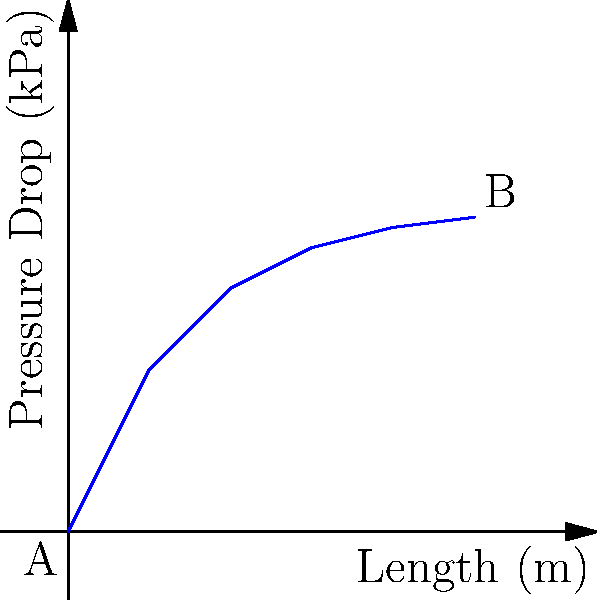In a pipe network used for competitor data collection, the pressure drop between points A and B follows the curve shown in the graph. If the flow rate in the pipe is 100 L/min, what is the approximate pressure drop per meter of pipe length at a distance of 3 meters from point A? To solve this problem, we need to follow these steps:

1. Identify the total pressure drop from point A to the 3-meter mark:
   From the graph, at x = 3 m, y ≈ 3.5 kPa

2. Calculate the pressure drop per meter:
   $$\text{Pressure drop per meter} = \frac{\text{Total pressure drop}}{\text{Distance}}$$
   $$\text{Pressure drop per meter} = \frac{3.5 \text{ kPa}}{3 \text{ m}} = 1.167 \text{ kPa/m}$$

3. However, this is an average value. To find the approximate pressure drop per meter at exactly 3 meters, we need to calculate the slope of the curve at that point.

4. To approximate the slope at 3 meters, we can use the values at 2 meters and 4 meters:
   At 2 m: y ≈ 3.0 kPa
   At 4 m: y ≈ 3.75 kPa

5. Calculate the slope:
   $$\text{Slope} = \frac{\text{Change in pressure}}{\text{Change in distance}} = \frac{3.75 \text{ kPa} - 3.0 \text{ kPa}}{4 \text{ m} - 2 \text{ m}} = \frac{0.75 \text{ kPa}}{2 \text{ m}} = 0.375 \text{ kPa/m}$$

This slope represents the approximate pressure drop per meter at 3 meters from point A.
Answer: 0.375 kPa/m 